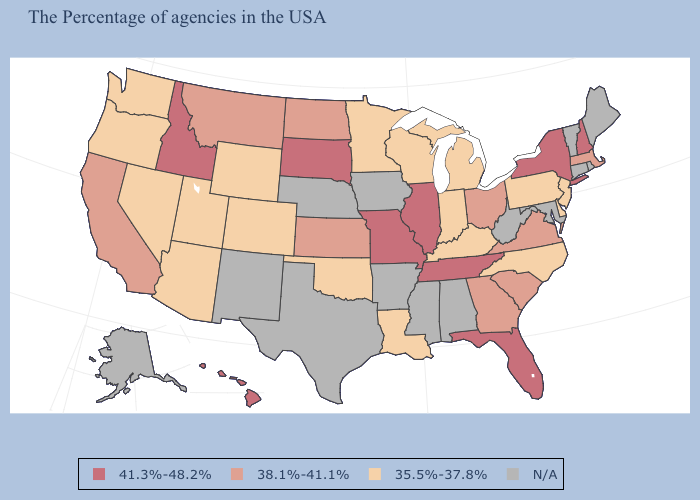What is the value of Montana?
Be succinct. 38.1%-41.1%. Does New York have the highest value in the USA?
Short answer required. Yes. Which states hav the highest value in the MidWest?
Write a very short answer. Illinois, Missouri, South Dakota. Name the states that have a value in the range N/A?
Concise answer only. Maine, Rhode Island, Vermont, Connecticut, Maryland, West Virginia, Alabama, Mississippi, Arkansas, Iowa, Nebraska, Texas, New Mexico, Alaska. Name the states that have a value in the range 41.3%-48.2%?
Short answer required. New Hampshire, New York, Florida, Tennessee, Illinois, Missouri, South Dakota, Idaho, Hawaii. Name the states that have a value in the range 41.3%-48.2%?
Write a very short answer. New Hampshire, New York, Florida, Tennessee, Illinois, Missouri, South Dakota, Idaho, Hawaii. How many symbols are there in the legend?
Be succinct. 4. Which states have the lowest value in the South?
Short answer required. Delaware, North Carolina, Kentucky, Louisiana, Oklahoma. Name the states that have a value in the range 41.3%-48.2%?
Write a very short answer. New Hampshire, New York, Florida, Tennessee, Illinois, Missouri, South Dakota, Idaho, Hawaii. How many symbols are there in the legend?
Short answer required. 4. Name the states that have a value in the range N/A?
Be succinct. Maine, Rhode Island, Vermont, Connecticut, Maryland, West Virginia, Alabama, Mississippi, Arkansas, Iowa, Nebraska, Texas, New Mexico, Alaska. Does the map have missing data?
Give a very brief answer. Yes. What is the value of South Dakota?
Quick response, please. 41.3%-48.2%. Does the map have missing data?
Keep it brief. Yes. 